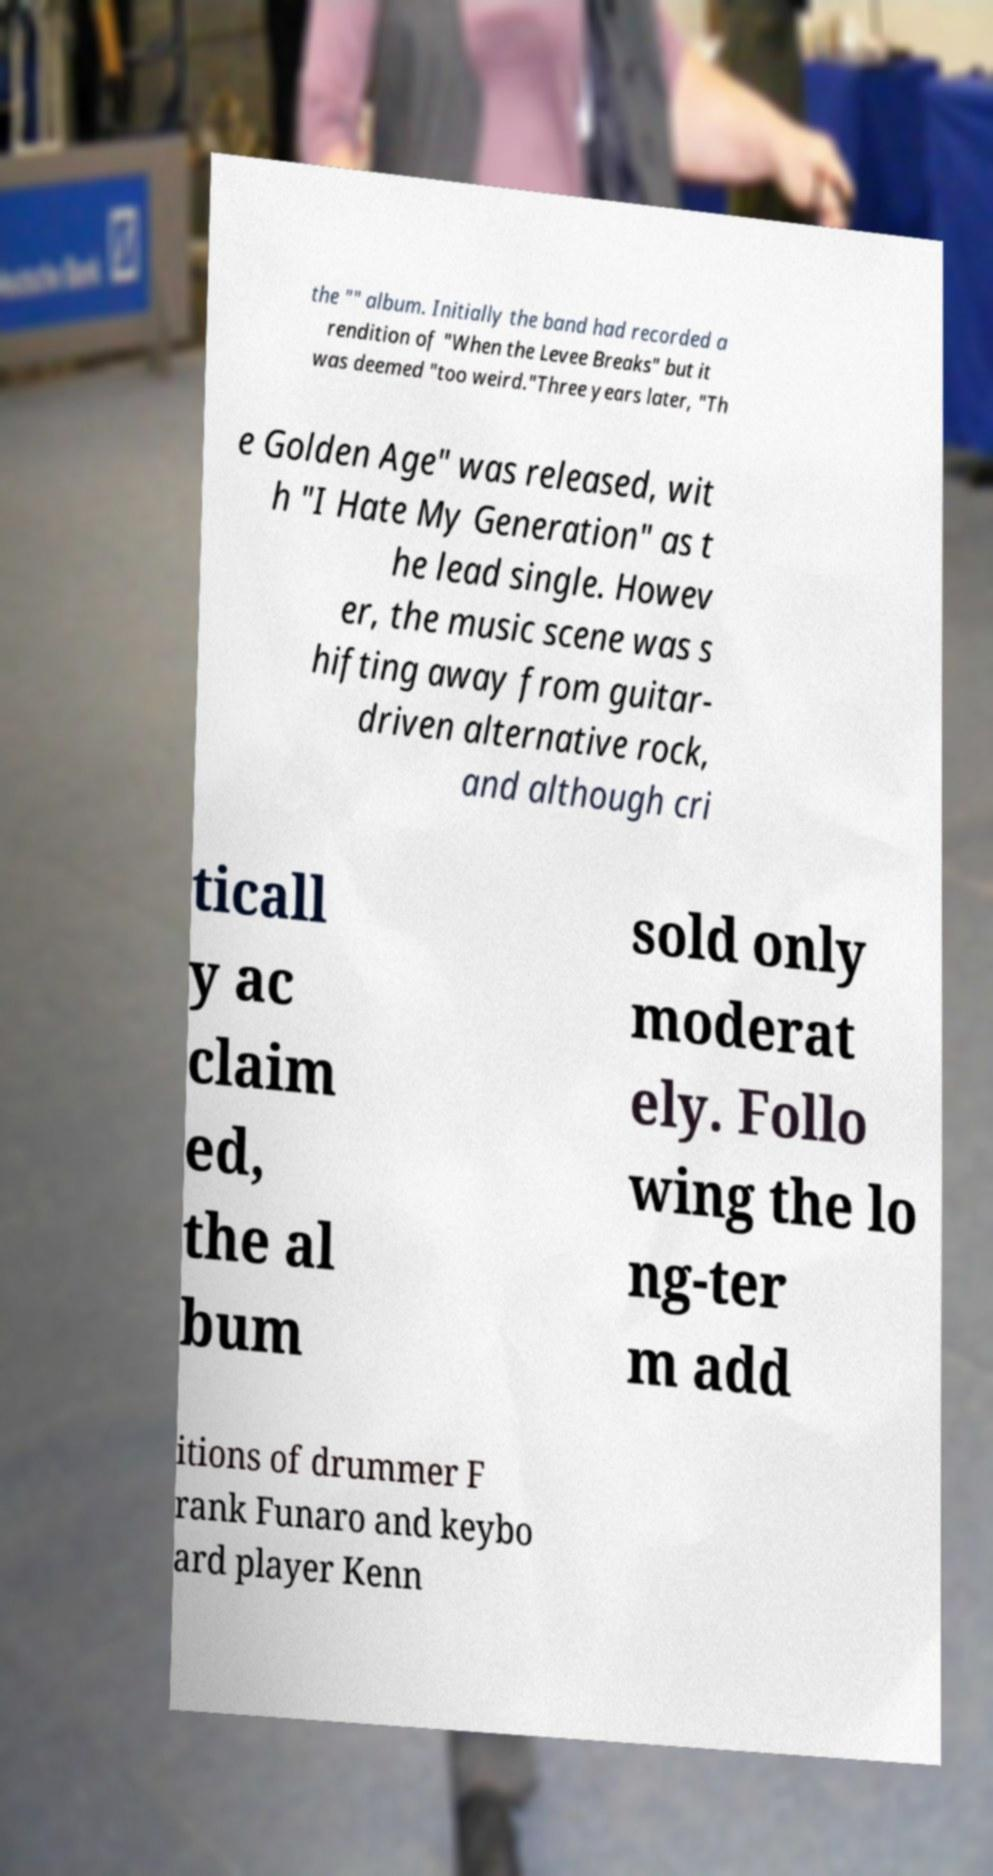Please read and relay the text visible in this image. What does it say? the "" album. Initially the band had recorded a rendition of "When the Levee Breaks" but it was deemed "too weird."Three years later, "Th e Golden Age" was released, wit h "I Hate My Generation" as t he lead single. Howev er, the music scene was s hifting away from guitar- driven alternative rock, and although cri ticall y ac claim ed, the al bum sold only moderat ely. Follo wing the lo ng-ter m add itions of drummer F rank Funaro and keybo ard player Kenn 